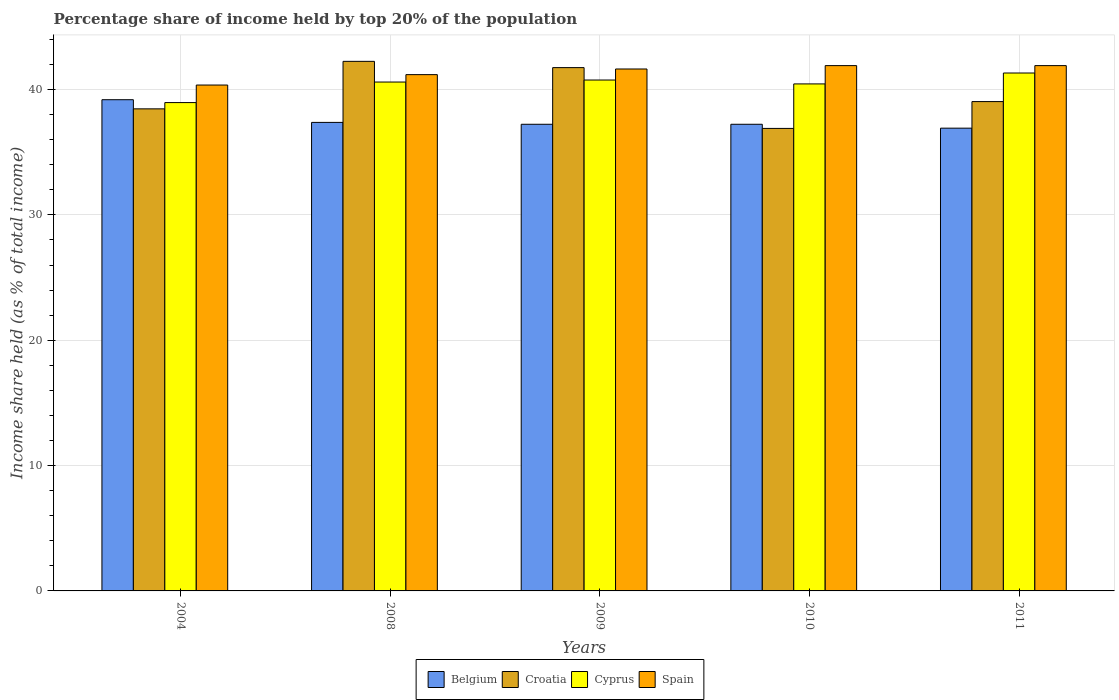How many different coloured bars are there?
Offer a very short reply. 4. How many groups of bars are there?
Provide a succinct answer. 5. Are the number of bars on each tick of the X-axis equal?
Offer a terse response. Yes. How many bars are there on the 4th tick from the left?
Provide a short and direct response. 4. What is the label of the 2nd group of bars from the left?
Offer a very short reply. 2008. In how many cases, is the number of bars for a given year not equal to the number of legend labels?
Offer a very short reply. 0. What is the percentage share of income held by top 20% of the population in Croatia in 2004?
Your answer should be very brief. 38.46. Across all years, what is the maximum percentage share of income held by top 20% of the population in Belgium?
Your answer should be very brief. 39.19. Across all years, what is the minimum percentage share of income held by top 20% of the population in Croatia?
Provide a succinct answer. 36.9. In which year was the percentage share of income held by top 20% of the population in Spain minimum?
Keep it short and to the point. 2004. What is the total percentage share of income held by top 20% of the population in Cyprus in the graph?
Provide a short and direct response. 202.09. What is the difference between the percentage share of income held by top 20% of the population in Spain in 2010 and that in 2011?
Offer a very short reply. 0. What is the difference between the percentage share of income held by top 20% of the population in Cyprus in 2011 and the percentage share of income held by top 20% of the population in Spain in 2004?
Give a very brief answer. 0.96. What is the average percentage share of income held by top 20% of the population in Cyprus per year?
Provide a succinct answer. 40.42. In the year 2004, what is the difference between the percentage share of income held by top 20% of the population in Belgium and percentage share of income held by top 20% of the population in Cyprus?
Your answer should be compact. 0.23. What is the ratio of the percentage share of income held by top 20% of the population in Spain in 2004 to that in 2011?
Your answer should be very brief. 0.96. What is the difference between the highest and the second highest percentage share of income held by top 20% of the population in Cyprus?
Provide a succinct answer. 0.56. What is the difference between the highest and the lowest percentage share of income held by top 20% of the population in Croatia?
Your response must be concise. 5.35. Is the sum of the percentage share of income held by top 20% of the population in Spain in 2004 and 2008 greater than the maximum percentage share of income held by top 20% of the population in Cyprus across all years?
Give a very brief answer. Yes. Is it the case that in every year, the sum of the percentage share of income held by top 20% of the population in Spain and percentage share of income held by top 20% of the population in Croatia is greater than the sum of percentage share of income held by top 20% of the population in Cyprus and percentage share of income held by top 20% of the population in Belgium?
Make the answer very short. No. What does the 1st bar from the left in 2010 represents?
Offer a terse response. Belgium. Is it the case that in every year, the sum of the percentage share of income held by top 20% of the population in Belgium and percentage share of income held by top 20% of the population in Croatia is greater than the percentage share of income held by top 20% of the population in Spain?
Your response must be concise. Yes. How many years are there in the graph?
Your answer should be very brief. 5. Does the graph contain any zero values?
Make the answer very short. No. How many legend labels are there?
Ensure brevity in your answer.  4. What is the title of the graph?
Offer a very short reply. Percentage share of income held by top 20% of the population. What is the label or title of the X-axis?
Offer a terse response. Years. What is the label or title of the Y-axis?
Provide a succinct answer. Income share held (as % of total income). What is the Income share held (as % of total income) in Belgium in 2004?
Ensure brevity in your answer.  39.19. What is the Income share held (as % of total income) in Croatia in 2004?
Offer a very short reply. 38.46. What is the Income share held (as % of total income) of Cyprus in 2004?
Your answer should be very brief. 38.96. What is the Income share held (as % of total income) in Spain in 2004?
Provide a short and direct response. 40.36. What is the Income share held (as % of total income) of Belgium in 2008?
Offer a very short reply. 37.38. What is the Income share held (as % of total income) in Croatia in 2008?
Keep it short and to the point. 42.25. What is the Income share held (as % of total income) in Cyprus in 2008?
Provide a succinct answer. 40.6. What is the Income share held (as % of total income) of Spain in 2008?
Give a very brief answer. 41.19. What is the Income share held (as % of total income) of Belgium in 2009?
Your answer should be very brief. 37.23. What is the Income share held (as % of total income) in Croatia in 2009?
Make the answer very short. 41.75. What is the Income share held (as % of total income) of Cyprus in 2009?
Ensure brevity in your answer.  40.76. What is the Income share held (as % of total income) in Spain in 2009?
Provide a succinct answer. 41.64. What is the Income share held (as % of total income) of Belgium in 2010?
Offer a terse response. 37.23. What is the Income share held (as % of total income) in Croatia in 2010?
Your response must be concise. 36.9. What is the Income share held (as % of total income) in Cyprus in 2010?
Make the answer very short. 40.45. What is the Income share held (as % of total income) of Spain in 2010?
Make the answer very short. 41.91. What is the Income share held (as % of total income) of Belgium in 2011?
Provide a succinct answer. 36.92. What is the Income share held (as % of total income) in Croatia in 2011?
Keep it short and to the point. 39.04. What is the Income share held (as % of total income) in Cyprus in 2011?
Offer a very short reply. 41.32. What is the Income share held (as % of total income) of Spain in 2011?
Offer a terse response. 41.91. Across all years, what is the maximum Income share held (as % of total income) of Belgium?
Provide a succinct answer. 39.19. Across all years, what is the maximum Income share held (as % of total income) in Croatia?
Ensure brevity in your answer.  42.25. Across all years, what is the maximum Income share held (as % of total income) in Cyprus?
Provide a succinct answer. 41.32. Across all years, what is the maximum Income share held (as % of total income) in Spain?
Offer a terse response. 41.91. Across all years, what is the minimum Income share held (as % of total income) of Belgium?
Make the answer very short. 36.92. Across all years, what is the minimum Income share held (as % of total income) of Croatia?
Offer a terse response. 36.9. Across all years, what is the minimum Income share held (as % of total income) of Cyprus?
Give a very brief answer. 38.96. Across all years, what is the minimum Income share held (as % of total income) in Spain?
Your answer should be very brief. 40.36. What is the total Income share held (as % of total income) in Belgium in the graph?
Provide a succinct answer. 187.95. What is the total Income share held (as % of total income) of Croatia in the graph?
Keep it short and to the point. 198.4. What is the total Income share held (as % of total income) in Cyprus in the graph?
Ensure brevity in your answer.  202.09. What is the total Income share held (as % of total income) in Spain in the graph?
Provide a short and direct response. 207.01. What is the difference between the Income share held (as % of total income) of Belgium in 2004 and that in 2008?
Make the answer very short. 1.81. What is the difference between the Income share held (as % of total income) of Croatia in 2004 and that in 2008?
Your answer should be very brief. -3.79. What is the difference between the Income share held (as % of total income) of Cyprus in 2004 and that in 2008?
Keep it short and to the point. -1.64. What is the difference between the Income share held (as % of total income) in Spain in 2004 and that in 2008?
Your response must be concise. -0.83. What is the difference between the Income share held (as % of total income) in Belgium in 2004 and that in 2009?
Ensure brevity in your answer.  1.96. What is the difference between the Income share held (as % of total income) in Croatia in 2004 and that in 2009?
Provide a succinct answer. -3.29. What is the difference between the Income share held (as % of total income) of Cyprus in 2004 and that in 2009?
Ensure brevity in your answer.  -1.8. What is the difference between the Income share held (as % of total income) of Spain in 2004 and that in 2009?
Your answer should be very brief. -1.28. What is the difference between the Income share held (as % of total income) of Belgium in 2004 and that in 2010?
Give a very brief answer. 1.96. What is the difference between the Income share held (as % of total income) of Croatia in 2004 and that in 2010?
Make the answer very short. 1.56. What is the difference between the Income share held (as % of total income) in Cyprus in 2004 and that in 2010?
Offer a very short reply. -1.49. What is the difference between the Income share held (as % of total income) in Spain in 2004 and that in 2010?
Provide a succinct answer. -1.55. What is the difference between the Income share held (as % of total income) of Belgium in 2004 and that in 2011?
Your answer should be compact. 2.27. What is the difference between the Income share held (as % of total income) in Croatia in 2004 and that in 2011?
Ensure brevity in your answer.  -0.58. What is the difference between the Income share held (as % of total income) in Cyprus in 2004 and that in 2011?
Provide a short and direct response. -2.36. What is the difference between the Income share held (as % of total income) of Spain in 2004 and that in 2011?
Your response must be concise. -1.55. What is the difference between the Income share held (as % of total income) of Belgium in 2008 and that in 2009?
Your answer should be compact. 0.15. What is the difference between the Income share held (as % of total income) in Croatia in 2008 and that in 2009?
Make the answer very short. 0.5. What is the difference between the Income share held (as % of total income) in Cyprus in 2008 and that in 2009?
Ensure brevity in your answer.  -0.16. What is the difference between the Income share held (as % of total income) in Spain in 2008 and that in 2009?
Your answer should be compact. -0.45. What is the difference between the Income share held (as % of total income) in Belgium in 2008 and that in 2010?
Ensure brevity in your answer.  0.15. What is the difference between the Income share held (as % of total income) in Croatia in 2008 and that in 2010?
Give a very brief answer. 5.35. What is the difference between the Income share held (as % of total income) of Cyprus in 2008 and that in 2010?
Your answer should be compact. 0.15. What is the difference between the Income share held (as % of total income) in Spain in 2008 and that in 2010?
Keep it short and to the point. -0.72. What is the difference between the Income share held (as % of total income) in Belgium in 2008 and that in 2011?
Your answer should be compact. 0.46. What is the difference between the Income share held (as % of total income) of Croatia in 2008 and that in 2011?
Your response must be concise. 3.21. What is the difference between the Income share held (as % of total income) of Cyprus in 2008 and that in 2011?
Offer a terse response. -0.72. What is the difference between the Income share held (as % of total income) of Spain in 2008 and that in 2011?
Your response must be concise. -0.72. What is the difference between the Income share held (as % of total income) of Belgium in 2009 and that in 2010?
Keep it short and to the point. 0. What is the difference between the Income share held (as % of total income) of Croatia in 2009 and that in 2010?
Give a very brief answer. 4.85. What is the difference between the Income share held (as % of total income) in Cyprus in 2009 and that in 2010?
Ensure brevity in your answer.  0.31. What is the difference between the Income share held (as % of total income) in Spain in 2009 and that in 2010?
Give a very brief answer. -0.27. What is the difference between the Income share held (as % of total income) in Belgium in 2009 and that in 2011?
Make the answer very short. 0.31. What is the difference between the Income share held (as % of total income) in Croatia in 2009 and that in 2011?
Your response must be concise. 2.71. What is the difference between the Income share held (as % of total income) in Cyprus in 2009 and that in 2011?
Offer a very short reply. -0.56. What is the difference between the Income share held (as % of total income) in Spain in 2009 and that in 2011?
Make the answer very short. -0.27. What is the difference between the Income share held (as % of total income) of Belgium in 2010 and that in 2011?
Provide a succinct answer. 0.31. What is the difference between the Income share held (as % of total income) in Croatia in 2010 and that in 2011?
Ensure brevity in your answer.  -2.14. What is the difference between the Income share held (as % of total income) of Cyprus in 2010 and that in 2011?
Your response must be concise. -0.87. What is the difference between the Income share held (as % of total income) in Belgium in 2004 and the Income share held (as % of total income) in Croatia in 2008?
Offer a very short reply. -3.06. What is the difference between the Income share held (as % of total income) of Belgium in 2004 and the Income share held (as % of total income) of Cyprus in 2008?
Offer a very short reply. -1.41. What is the difference between the Income share held (as % of total income) of Belgium in 2004 and the Income share held (as % of total income) of Spain in 2008?
Keep it short and to the point. -2. What is the difference between the Income share held (as % of total income) of Croatia in 2004 and the Income share held (as % of total income) of Cyprus in 2008?
Your answer should be very brief. -2.14. What is the difference between the Income share held (as % of total income) of Croatia in 2004 and the Income share held (as % of total income) of Spain in 2008?
Give a very brief answer. -2.73. What is the difference between the Income share held (as % of total income) of Cyprus in 2004 and the Income share held (as % of total income) of Spain in 2008?
Offer a terse response. -2.23. What is the difference between the Income share held (as % of total income) of Belgium in 2004 and the Income share held (as % of total income) of Croatia in 2009?
Offer a very short reply. -2.56. What is the difference between the Income share held (as % of total income) in Belgium in 2004 and the Income share held (as % of total income) in Cyprus in 2009?
Offer a terse response. -1.57. What is the difference between the Income share held (as % of total income) in Belgium in 2004 and the Income share held (as % of total income) in Spain in 2009?
Your answer should be very brief. -2.45. What is the difference between the Income share held (as % of total income) in Croatia in 2004 and the Income share held (as % of total income) in Cyprus in 2009?
Make the answer very short. -2.3. What is the difference between the Income share held (as % of total income) in Croatia in 2004 and the Income share held (as % of total income) in Spain in 2009?
Your answer should be compact. -3.18. What is the difference between the Income share held (as % of total income) of Cyprus in 2004 and the Income share held (as % of total income) of Spain in 2009?
Provide a succinct answer. -2.68. What is the difference between the Income share held (as % of total income) of Belgium in 2004 and the Income share held (as % of total income) of Croatia in 2010?
Give a very brief answer. 2.29. What is the difference between the Income share held (as % of total income) of Belgium in 2004 and the Income share held (as % of total income) of Cyprus in 2010?
Your answer should be compact. -1.26. What is the difference between the Income share held (as % of total income) in Belgium in 2004 and the Income share held (as % of total income) in Spain in 2010?
Provide a succinct answer. -2.72. What is the difference between the Income share held (as % of total income) of Croatia in 2004 and the Income share held (as % of total income) of Cyprus in 2010?
Your answer should be compact. -1.99. What is the difference between the Income share held (as % of total income) of Croatia in 2004 and the Income share held (as % of total income) of Spain in 2010?
Your answer should be very brief. -3.45. What is the difference between the Income share held (as % of total income) of Cyprus in 2004 and the Income share held (as % of total income) of Spain in 2010?
Your response must be concise. -2.95. What is the difference between the Income share held (as % of total income) of Belgium in 2004 and the Income share held (as % of total income) of Cyprus in 2011?
Provide a succinct answer. -2.13. What is the difference between the Income share held (as % of total income) of Belgium in 2004 and the Income share held (as % of total income) of Spain in 2011?
Provide a succinct answer. -2.72. What is the difference between the Income share held (as % of total income) in Croatia in 2004 and the Income share held (as % of total income) in Cyprus in 2011?
Provide a short and direct response. -2.86. What is the difference between the Income share held (as % of total income) in Croatia in 2004 and the Income share held (as % of total income) in Spain in 2011?
Make the answer very short. -3.45. What is the difference between the Income share held (as % of total income) of Cyprus in 2004 and the Income share held (as % of total income) of Spain in 2011?
Your answer should be compact. -2.95. What is the difference between the Income share held (as % of total income) of Belgium in 2008 and the Income share held (as % of total income) of Croatia in 2009?
Your response must be concise. -4.37. What is the difference between the Income share held (as % of total income) in Belgium in 2008 and the Income share held (as % of total income) in Cyprus in 2009?
Provide a short and direct response. -3.38. What is the difference between the Income share held (as % of total income) of Belgium in 2008 and the Income share held (as % of total income) of Spain in 2009?
Give a very brief answer. -4.26. What is the difference between the Income share held (as % of total income) in Croatia in 2008 and the Income share held (as % of total income) in Cyprus in 2009?
Keep it short and to the point. 1.49. What is the difference between the Income share held (as % of total income) in Croatia in 2008 and the Income share held (as % of total income) in Spain in 2009?
Provide a succinct answer. 0.61. What is the difference between the Income share held (as % of total income) in Cyprus in 2008 and the Income share held (as % of total income) in Spain in 2009?
Offer a very short reply. -1.04. What is the difference between the Income share held (as % of total income) of Belgium in 2008 and the Income share held (as % of total income) of Croatia in 2010?
Ensure brevity in your answer.  0.48. What is the difference between the Income share held (as % of total income) of Belgium in 2008 and the Income share held (as % of total income) of Cyprus in 2010?
Ensure brevity in your answer.  -3.07. What is the difference between the Income share held (as % of total income) in Belgium in 2008 and the Income share held (as % of total income) in Spain in 2010?
Your answer should be very brief. -4.53. What is the difference between the Income share held (as % of total income) in Croatia in 2008 and the Income share held (as % of total income) in Spain in 2010?
Make the answer very short. 0.34. What is the difference between the Income share held (as % of total income) of Cyprus in 2008 and the Income share held (as % of total income) of Spain in 2010?
Keep it short and to the point. -1.31. What is the difference between the Income share held (as % of total income) of Belgium in 2008 and the Income share held (as % of total income) of Croatia in 2011?
Keep it short and to the point. -1.66. What is the difference between the Income share held (as % of total income) in Belgium in 2008 and the Income share held (as % of total income) in Cyprus in 2011?
Your answer should be compact. -3.94. What is the difference between the Income share held (as % of total income) in Belgium in 2008 and the Income share held (as % of total income) in Spain in 2011?
Offer a terse response. -4.53. What is the difference between the Income share held (as % of total income) in Croatia in 2008 and the Income share held (as % of total income) in Cyprus in 2011?
Ensure brevity in your answer.  0.93. What is the difference between the Income share held (as % of total income) in Croatia in 2008 and the Income share held (as % of total income) in Spain in 2011?
Offer a very short reply. 0.34. What is the difference between the Income share held (as % of total income) of Cyprus in 2008 and the Income share held (as % of total income) of Spain in 2011?
Provide a short and direct response. -1.31. What is the difference between the Income share held (as % of total income) of Belgium in 2009 and the Income share held (as % of total income) of Croatia in 2010?
Make the answer very short. 0.33. What is the difference between the Income share held (as % of total income) of Belgium in 2009 and the Income share held (as % of total income) of Cyprus in 2010?
Offer a terse response. -3.22. What is the difference between the Income share held (as % of total income) in Belgium in 2009 and the Income share held (as % of total income) in Spain in 2010?
Your response must be concise. -4.68. What is the difference between the Income share held (as % of total income) of Croatia in 2009 and the Income share held (as % of total income) of Spain in 2010?
Offer a terse response. -0.16. What is the difference between the Income share held (as % of total income) of Cyprus in 2009 and the Income share held (as % of total income) of Spain in 2010?
Your answer should be compact. -1.15. What is the difference between the Income share held (as % of total income) of Belgium in 2009 and the Income share held (as % of total income) of Croatia in 2011?
Your answer should be very brief. -1.81. What is the difference between the Income share held (as % of total income) in Belgium in 2009 and the Income share held (as % of total income) in Cyprus in 2011?
Ensure brevity in your answer.  -4.09. What is the difference between the Income share held (as % of total income) in Belgium in 2009 and the Income share held (as % of total income) in Spain in 2011?
Provide a short and direct response. -4.68. What is the difference between the Income share held (as % of total income) in Croatia in 2009 and the Income share held (as % of total income) in Cyprus in 2011?
Keep it short and to the point. 0.43. What is the difference between the Income share held (as % of total income) of Croatia in 2009 and the Income share held (as % of total income) of Spain in 2011?
Keep it short and to the point. -0.16. What is the difference between the Income share held (as % of total income) in Cyprus in 2009 and the Income share held (as % of total income) in Spain in 2011?
Keep it short and to the point. -1.15. What is the difference between the Income share held (as % of total income) in Belgium in 2010 and the Income share held (as % of total income) in Croatia in 2011?
Offer a very short reply. -1.81. What is the difference between the Income share held (as % of total income) of Belgium in 2010 and the Income share held (as % of total income) of Cyprus in 2011?
Offer a terse response. -4.09. What is the difference between the Income share held (as % of total income) of Belgium in 2010 and the Income share held (as % of total income) of Spain in 2011?
Provide a succinct answer. -4.68. What is the difference between the Income share held (as % of total income) of Croatia in 2010 and the Income share held (as % of total income) of Cyprus in 2011?
Provide a short and direct response. -4.42. What is the difference between the Income share held (as % of total income) of Croatia in 2010 and the Income share held (as % of total income) of Spain in 2011?
Your response must be concise. -5.01. What is the difference between the Income share held (as % of total income) of Cyprus in 2010 and the Income share held (as % of total income) of Spain in 2011?
Your response must be concise. -1.46. What is the average Income share held (as % of total income) of Belgium per year?
Provide a short and direct response. 37.59. What is the average Income share held (as % of total income) of Croatia per year?
Provide a short and direct response. 39.68. What is the average Income share held (as % of total income) in Cyprus per year?
Ensure brevity in your answer.  40.42. What is the average Income share held (as % of total income) in Spain per year?
Provide a short and direct response. 41.4. In the year 2004, what is the difference between the Income share held (as % of total income) in Belgium and Income share held (as % of total income) in Croatia?
Offer a terse response. 0.73. In the year 2004, what is the difference between the Income share held (as % of total income) of Belgium and Income share held (as % of total income) of Cyprus?
Your response must be concise. 0.23. In the year 2004, what is the difference between the Income share held (as % of total income) of Belgium and Income share held (as % of total income) of Spain?
Your answer should be compact. -1.17. In the year 2004, what is the difference between the Income share held (as % of total income) of Croatia and Income share held (as % of total income) of Cyprus?
Your response must be concise. -0.5. In the year 2004, what is the difference between the Income share held (as % of total income) of Croatia and Income share held (as % of total income) of Spain?
Your answer should be compact. -1.9. In the year 2008, what is the difference between the Income share held (as % of total income) in Belgium and Income share held (as % of total income) in Croatia?
Your answer should be very brief. -4.87. In the year 2008, what is the difference between the Income share held (as % of total income) of Belgium and Income share held (as % of total income) of Cyprus?
Give a very brief answer. -3.22. In the year 2008, what is the difference between the Income share held (as % of total income) in Belgium and Income share held (as % of total income) in Spain?
Keep it short and to the point. -3.81. In the year 2008, what is the difference between the Income share held (as % of total income) of Croatia and Income share held (as % of total income) of Cyprus?
Provide a succinct answer. 1.65. In the year 2008, what is the difference between the Income share held (as % of total income) of Croatia and Income share held (as % of total income) of Spain?
Provide a succinct answer. 1.06. In the year 2008, what is the difference between the Income share held (as % of total income) of Cyprus and Income share held (as % of total income) of Spain?
Keep it short and to the point. -0.59. In the year 2009, what is the difference between the Income share held (as % of total income) of Belgium and Income share held (as % of total income) of Croatia?
Make the answer very short. -4.52. In the year 2009, what is the difference between the Income share held (as % of total income) of Belgium and Income share held (as % of total income) of Cyprus?
Provide a short and direct response. -3.53. In the year 2009, what is the difference between the Income share held (as % of total income) of Belgium and Income share held (as % of total income) of Spain?
Your answer should be compact. -4.41. In the year 2009, what is the difference between the Income share held (as % of total income) in Croatia and Income share held (as % of total income) in Spain?
Your answer should be compact. 0.11. In the year 2009, what is the difference between the Income share held (as % of total income) in Cyprus and Income share held (as % of total income) in Spain?
Give a very brief answer. -0.88. In the year 2010, what is the difference between the Income share held (as % of total income) in Belgium and Income share held (as % of total income) in Croatia?
Ensure brevity in your answer.  0.33. In the year 2010, what is the difference between the Income share held (as % of total income) in Belgium and Income share held (as % of total income) in Cyprus?
Your response must be concise. -3.22. In the year 2010, what is the difference between the Income share held (as % of total income) in Belgium and Income share held (as % of total income) in Spain?
Make the answer very short. -4.68. In the year 2010, what is the difference between the Income share held (as % of total income) in Croatia and Income share held (as % of total income) in Cyprus?
Keep it short and to the point. -3.55. In the year 2010, what is the difference between the Income share held (as % of total income) in Croatia and Income share held (as % of total income) in Spain?
Provide a succinct answer. -5.01. In the year 2010, what is the difference between the Income share held (as % of total income) of Cyprus and Income share held (as % of total income) of Spain?
Your answer should be compact. -1.46. In the year 2011, what is the difference between the Income share held (as % of total income) in Belgium and Income share held (as % of total income) in Croatia?
Provide a succinct answer. -2.12. In the year 2011, what is the difference between the Income share held (as % of total income) of Belgium and Income share held (as % of total income) of Spain?
Your answer should be compact. -4.99. In the year 2011, what is the difference between the Income share held (as % of total income) in Croatia and Income share held (as % of total income) in Cyprus?
Your response must be concise. -2.28. In the year 2011, what is the difference between the Income share held (as % of total income) in Croatia and Income share held (as % of total income) in Spain?
Provide a short and direct response. -2.87. In the year 2011, what is the difference between the Income share held (as % of total income) in Cyprus and Income share held (as % of total income) in Spain?
Provide a short and direct response. -0.59. What is the ratio of the Income share held (as % of total income) of Belgium in 2004 to that in 2008?
Your response must be concise. 1.05. What is the ratio of the Income share held (as % of total income) in Croatia in 2004 to that in 2008?
Provide a short and direct response. 0.91. What is the ratio of the Income share held (as % of total income) in Cyprus in 2004 to that in 2008?
Provide a succinct answer. 0.96. What is the ratio of the Income share held (as % of total income) in Spain in 2004 to that in 2008?
Your answer should be compact. 0.98. What is the ratio of the Income share held (as % of total income) of Belgium in 2004 to that in 2009?
Provide a succinct answer. 1.05. What is the ratio of the Income share held (as % of total income) of Croatia in 2004 to that in 2009?
Keep it short and to the point. 0.92. What is the ratio of the Income share held (as % of total income) in Cyprus in 2004 to that in 2009?
Keep it short and to the point. 0.96. What is the ratio of the Income share held (as % of total income) of Spain in 2004 to that in 2009?
Your response must be concise. 0.97. What is the ratio of the Income share held (as % of total income) of Belgium in 2004 to that in 2010?
Make the answer very short. 1.05. What is the ratio of the Income share held (as % of total income) of Croatia in 2004 to that in 2010?
Give a very brief answer. 1.04. What is the ratio of the Income share held (as % of total income) in Cyprus in 2004 to that in 2010?
Your answer should be compact. 0.96. What is the ratio of the Income share held (as % of total income) in Belgium in 2004 to that in 2011?
Your answer should be very brief. 1.06. What is the ratio of the Income share held (as % of total income) in Croatia in 2004 to that in 2011?
Your answer should be compact. 0.99. What is the ratio of the Income share held (as % of total income) of Cyprus in 2004 to that in 2011?
Your response must be concise. 0.94. What is the ratio of the Income share held (as % of total income) in Belgium in 2008 to that in 2010?
Make the answer very short. 1. What is the ratio of the Income share held (as % of total income) in Croatia in 2008 to that in 2010?
Give a very brief answer. 1.15. What is the ratio of the Income share held (as % of total income) in Spain in 2008 to that in 2010?
Ensure brevity in your answer.  0.98. What is the ratio of the Income share held (as % of total income) in Belgium in 2008 to that in 2011?
Provide a short and direct response. 1.01. What is the ratio of the Income share held (as % of total income) of Croatia in 2008 to that in 2011?
Give a very brief answer. 1.08. What is the ratio of the Income share held (as % of total income) in Cyprus in 2008 to that in 2011?
Keep it short and to the point. 0.98. What is the ratio of the Income share held (as % of total income) of Spain in 2008 to that in 2011?
Give a very brief answer. 0.98. What is the ratio of the Income share held (as % of total income) in Croatia in 2009 to that in 2010?
Offer a very short reply. 1.13. What is the ratio of the Income share held (as % of total income) in Cyprus in 2009 to that in 2010?
Offer a terse response. 1.01. What is the ratio of the Income share held (as % of total income) in Belgium in 2009 to that in 2011?
Provide a short and direct response. 1.01. What is the ratio of the Income share held (as % of total income) of Croatia in 2009 to that in 2011?
Your response must be concise. 1.07. What is the ratio of the Income share held (as % of total income) in Cyprus in 2009 to that in 2011?
Give a very brief answer. 0.99. What is the ratio of the Income share held (as % of total income) in Belgium in 2010 to that in 2011?
Offer a terse response. 1.01. What is the ratio of the Income share held (as % of total income) in Croatia in 2010 to that in 2011?
Give a very brief answer. 0.95. What is the ratio of the Income share held (as % of total income) of Cyprus in 2010 to that in 2011?
Provide a short and direct response. 0.98. What is the ratio of the Income share held (as % of total income) in Spain in 2010 to that in 2011?
Offer a very short reply. 1. What is the difference between the highest and the second highest Income share held (as % of total income) of Belgium?
Your answer should be very brief. 1.81. What is the difference between the highest and the second highest Income share held (as % of total income) of Croatia?
Keep it short and to the point. 0.5. What is the difference between the highest and the second highest Income share held (as % of total income) of Cyprus?
Give a very brief answer. 0.56. What is the difference between the highest and the lowest Income share held (as % of total income) in Belgium?
Provide a succinct answer. 2.27. What is the difference between the highest and the lowest Income share held (as % of total income) of Croatia?
Provide a succinct answer. 5.35. What is the difference between the highest and the lowest Income share held (as % of total income) in Cyprus?
Ensure brevity in your answer.  2.36. What is the difference between the highest and the lowest Income share held (as % of total income) of Spain?
Your answer should be compact. 1.55. 